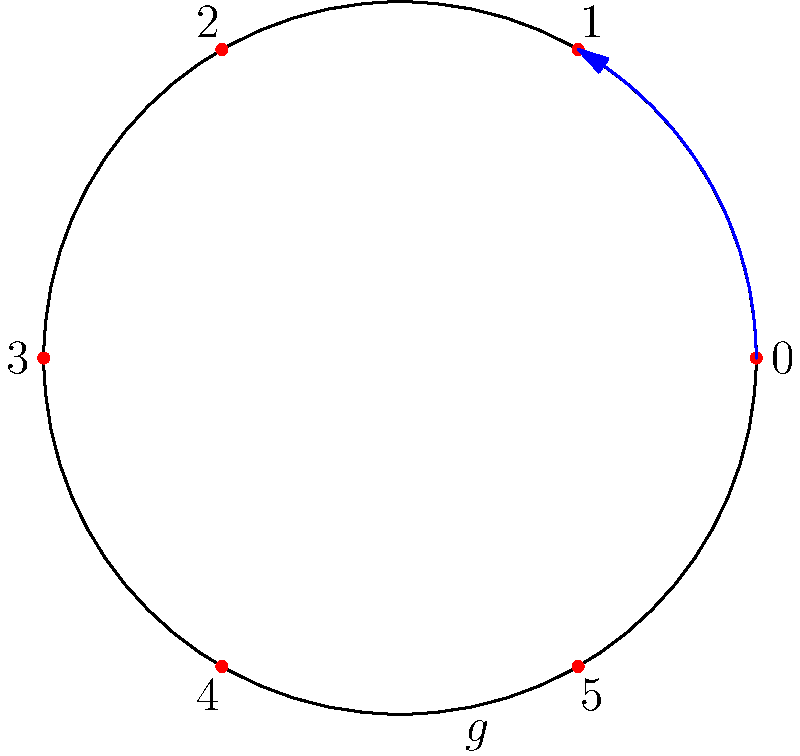In a popular open-world game, the day-night cycle repeats every 6 in-game hours. This cycle can be represented by a cyclic group of order 6. If $g$ represents the operation of advancing time by 1 hour, what element of the group represents advancing time by 4 hours? Let's approach this step-by-step:

1) The cyclic group of order 6 can be represented as $C_6 = \{e, g, g^2, g^3, g^4, g^5\}$, where $e$ is the identity element and $g$ is the generator.

2) In this representation:
   - $e$ represents no time change (0 hours)
   - $g$ represents advancing time by 1 hour
   - $g^2$ represents advancing time by 2 hours
   - and so on...

3) To advance time by 4 hours, we need to apply the operation $g$ four times.

4) In group theory notation, this is represented as $g^4$.

5) We can verify this:
   - $g^4 = g \cdot g \cdot g \cdot g$ (four 1-hour advancements)
   - This indeed represents a 4-hour advancement in the game's day-night cycle.

6) Note that in $C_6$, $g^6 = e$, which correctly represents that after 6 hours, we're back to the starting point in the cycle.
Answer: $g^4$ 